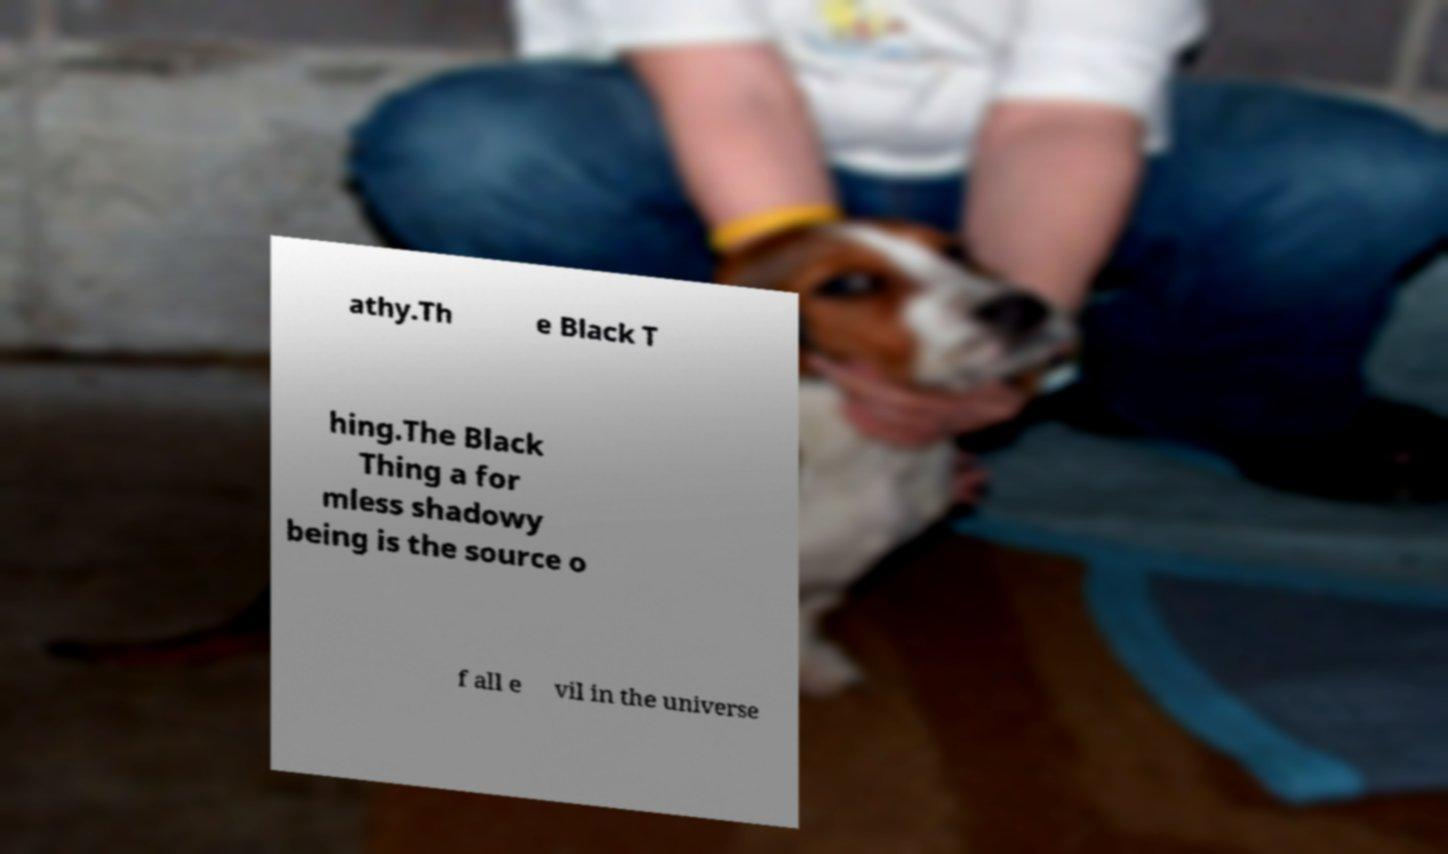Could you extract and type out the text from this image? athy.Th e Black T hing.The Black Thing a for mless shadowy being is the source o f all e vil in the universe 